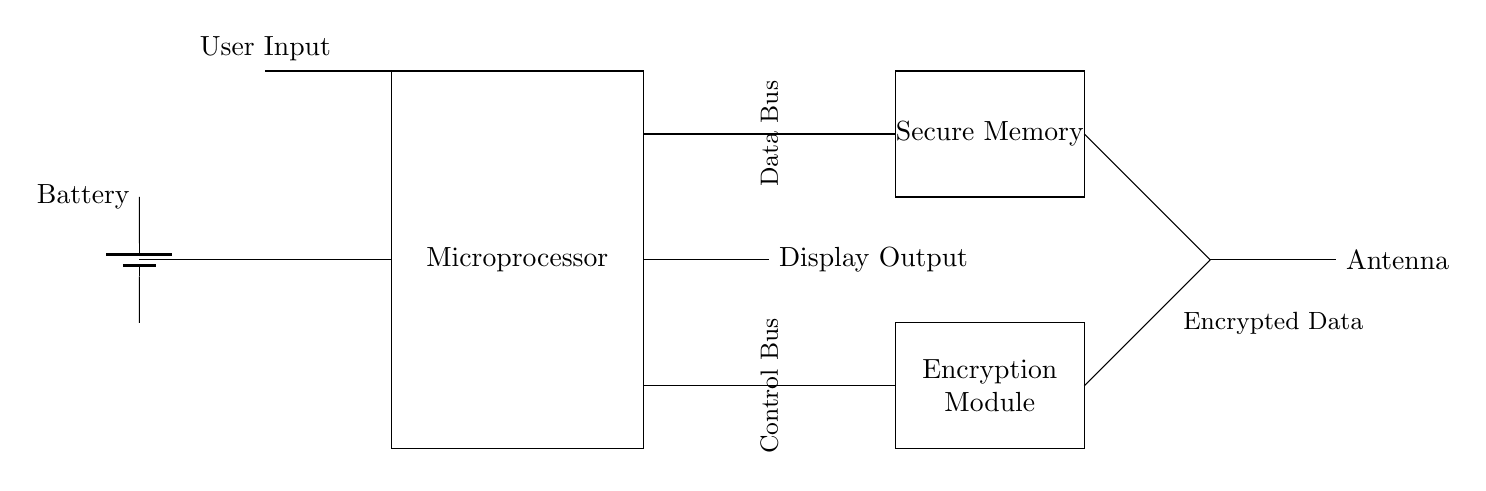What is the primary function of the Encryption Module? The primary function of the Encryption Module is to secure data by encoding it to protect user information during transmission. This is indicated by its connection to the data path and label.
Answer: secure data Which component connects to the Battery? The Microprocessor connects to the Battery; it is indicated by the direct line from the Battery to the Microprocessor, which shows the power supply.
Answer: Microprocessor What types of buses are shown in the circuit? The circuit displays two types of buses: the Data Bus and the Control Bus, each labeled and oriented vertically in the diagram.
Answer: Data and Control Which component outputs Display Output? The Microprocessor outputs Display Output, as seen from the line connecting it to the Display Output, which is drawn at the right side of the Microprocessor.
Answer: Microprocessor Why is Secure Memory connected to the Microprocessor? Secure Memory is connected to the Microprocessor to allow the Microprocessor to read from and write to it, facilitating the secure storage and retrieval of encrypted data. This connection is essential for data processing in secure operations.
Answer: Data processing What does the Antenna transmit? The Antenna transmits Encrypted Data, as indicated by the arrow connecting it to the Secure Memory, which sends the encoded information.
Answer: Encrypted Data 